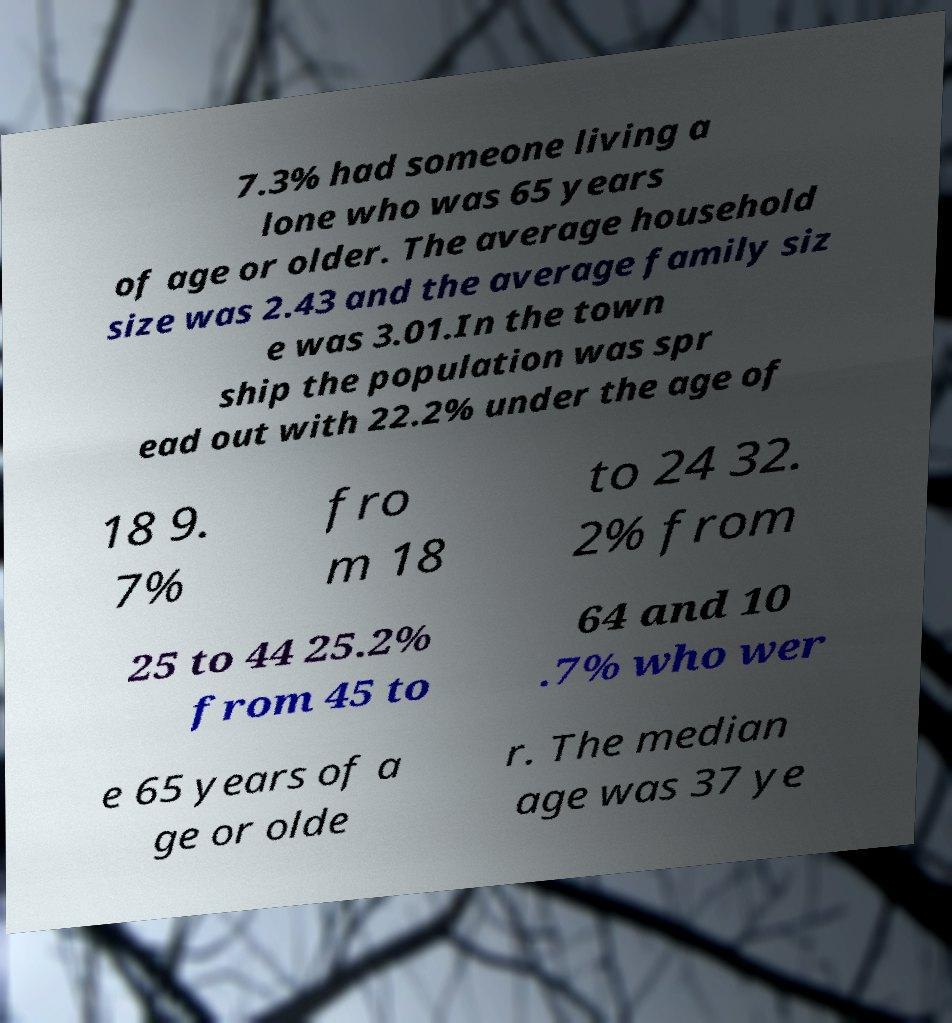For documentation purposes, I need the text within this image transcribed. Could you provide that? 7.3% had someone living a lone who was 65 years of age or older. The average household size was 2.43 and the average family siz e was 3.01.In the town ship the population was spr ead out with 22.2% under the age of 18 9. 7% fro m 18 to 24 32. 2% from 25 to 44 25.2% from 45 to 64 and 10 .7% who wer e 65 years of a ge or olde r. The median age was 37 ye 